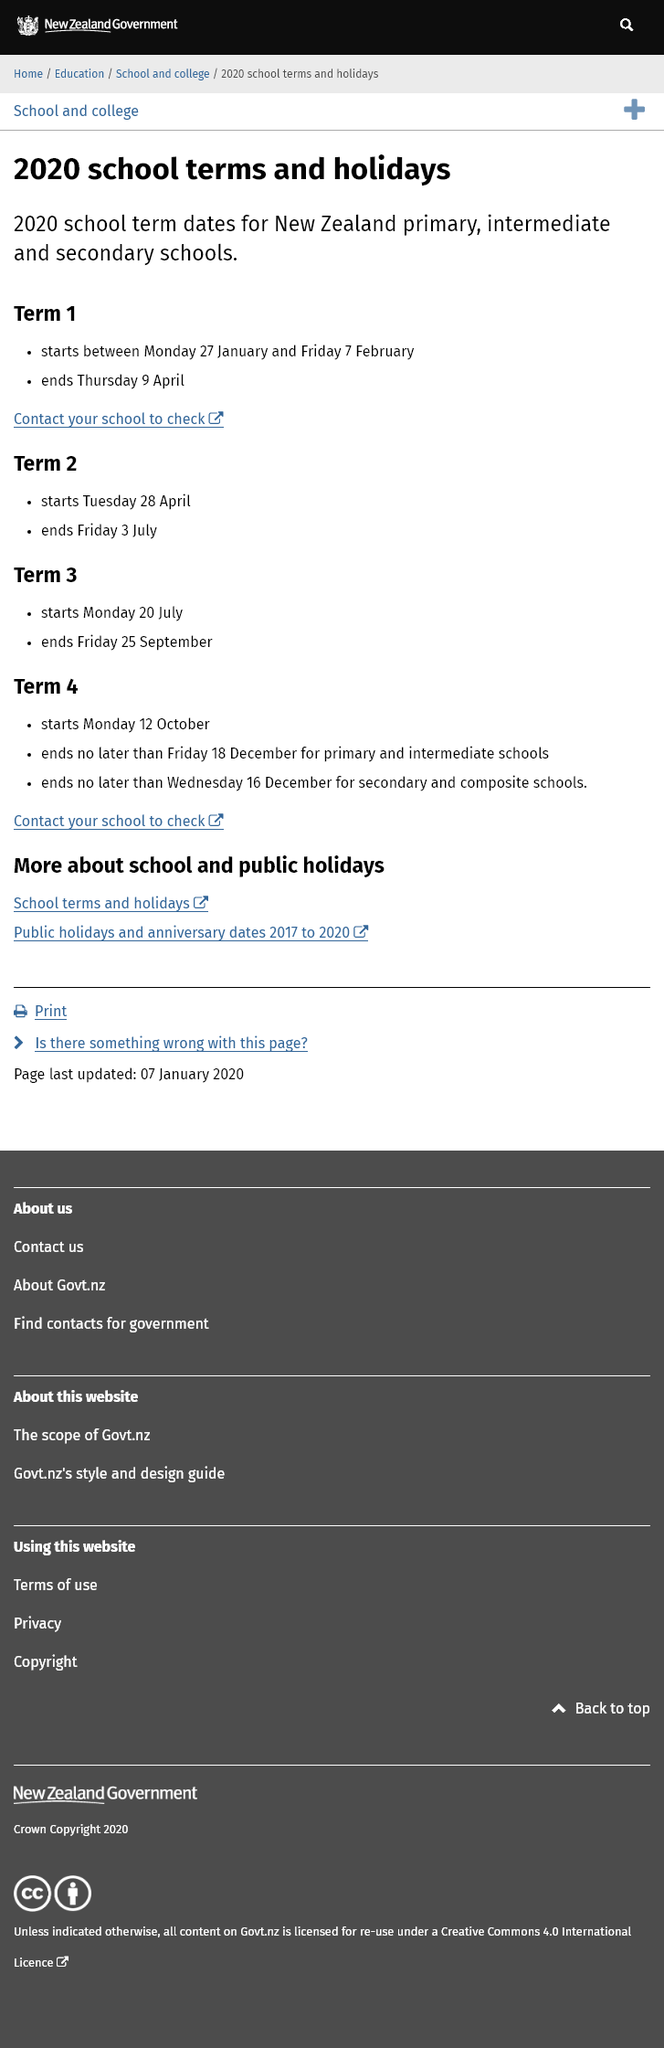Highlight a few significant elements in this photo. Term 3 will begin on Monday, 20 July. Term 1 will commence between Monday, 27 January and Friday, 7 February. Term 1 will end on Thursday, April 9th. 